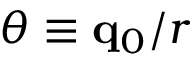<formula> <loc_0><loc_0><loc_500><loc_500>\theta \equiv q _ { 0 } / r</formula> 